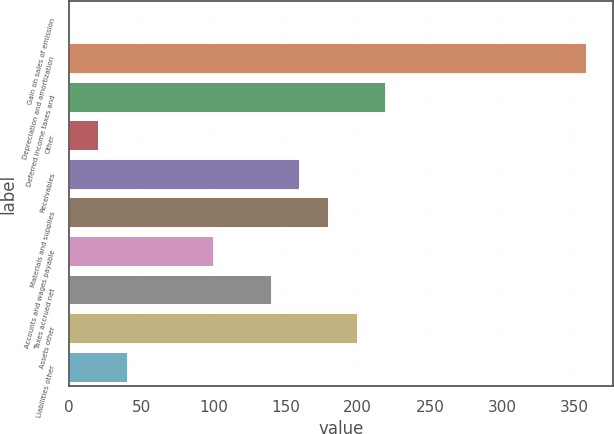Convert chart to OTSL. <chart><loc_0><loc_0><loc_500><loc_500><bar_chart><fcel>Gain on sales of emission<fcel>Depreciation and amortization<fcel>Deferred income taxes and<fcel>Other<fcel>Receivables<fcel>Materials and supplies<fcel>Accounts and wages payable<fcel>Taxes accrued net<fcel>Assets other<fcel>Liabilities other<nl><fcel>1<fcel>359.2<fcel>219.9<fcel>20.9<fcel>160.2<fcel>180.1<fcel>100.5<fcel>140.3<fcel>200<fcel>40.8<nl></chart> 